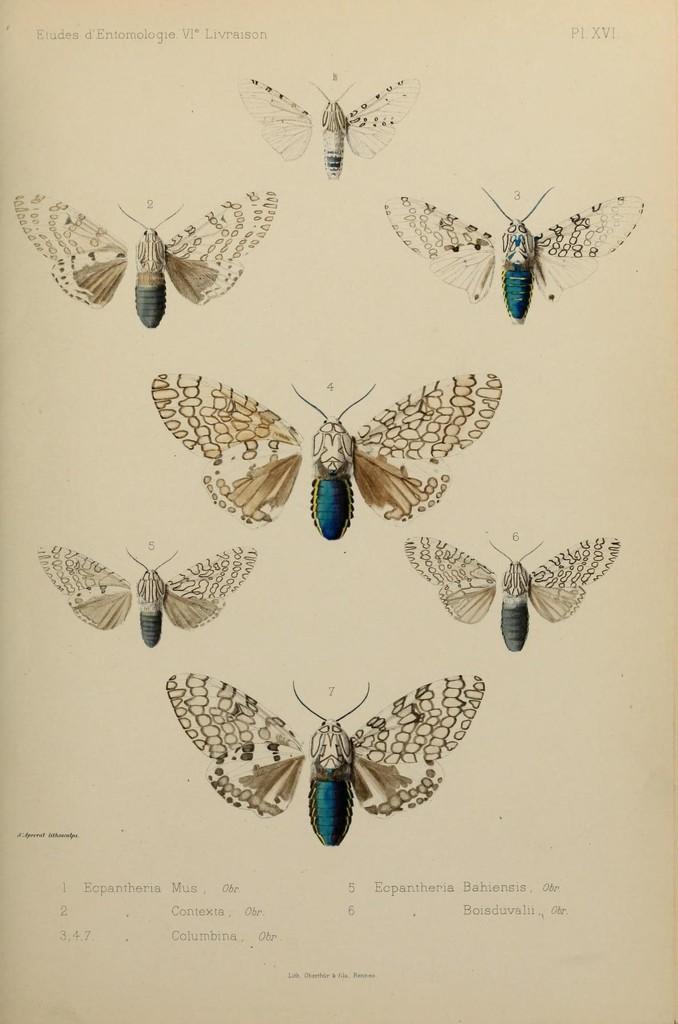Could you give a brief overview of what you see in this image? Here, we can see a photo, there are some butterflies in that photo. 